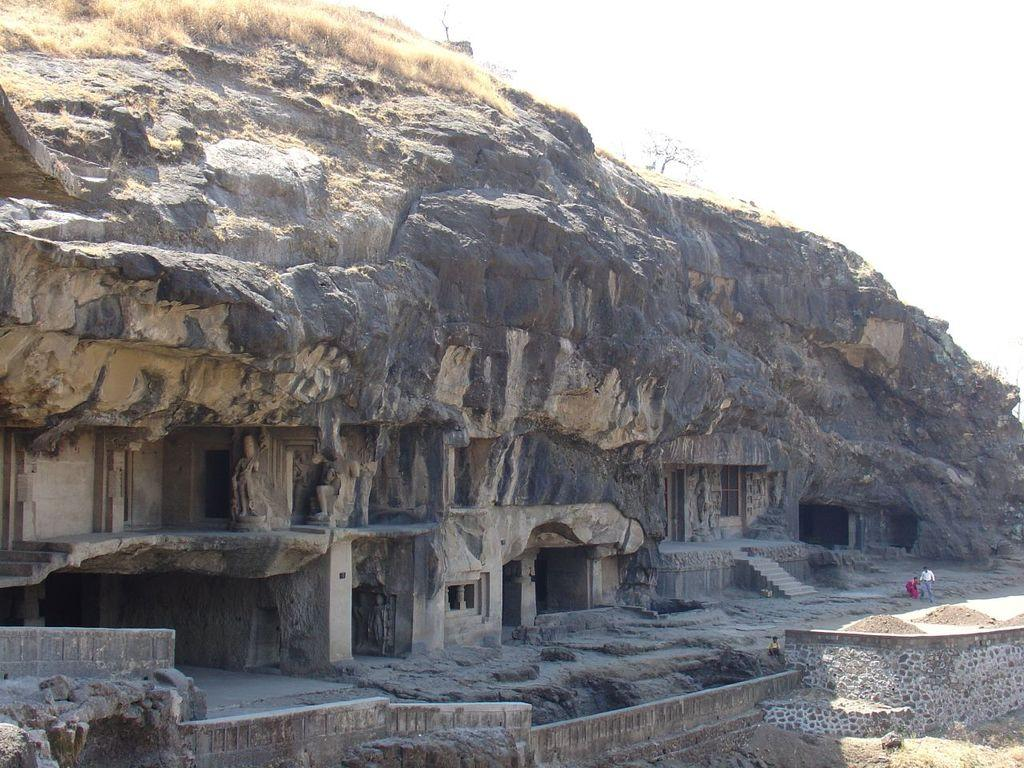What type of natural formation can be seen in the image? There are caves in the image. What architectural feature is present in the image? There are stairs in the image. What is the terrain like in the image? The ground is visible in the image, and there is grass present. Who or what is visible in the image? There are people in the image. What type of vegetation can be seen in the image? There is a tree in the image. What part of the natural environment is visible in the image? The sky is visible in the image. How many children are using forks to eat in the image? There are no children or forks present in the image. What type of natural disaster is occurring in the image? There is no indication of an earthquake or any other natural disaster in the image. 